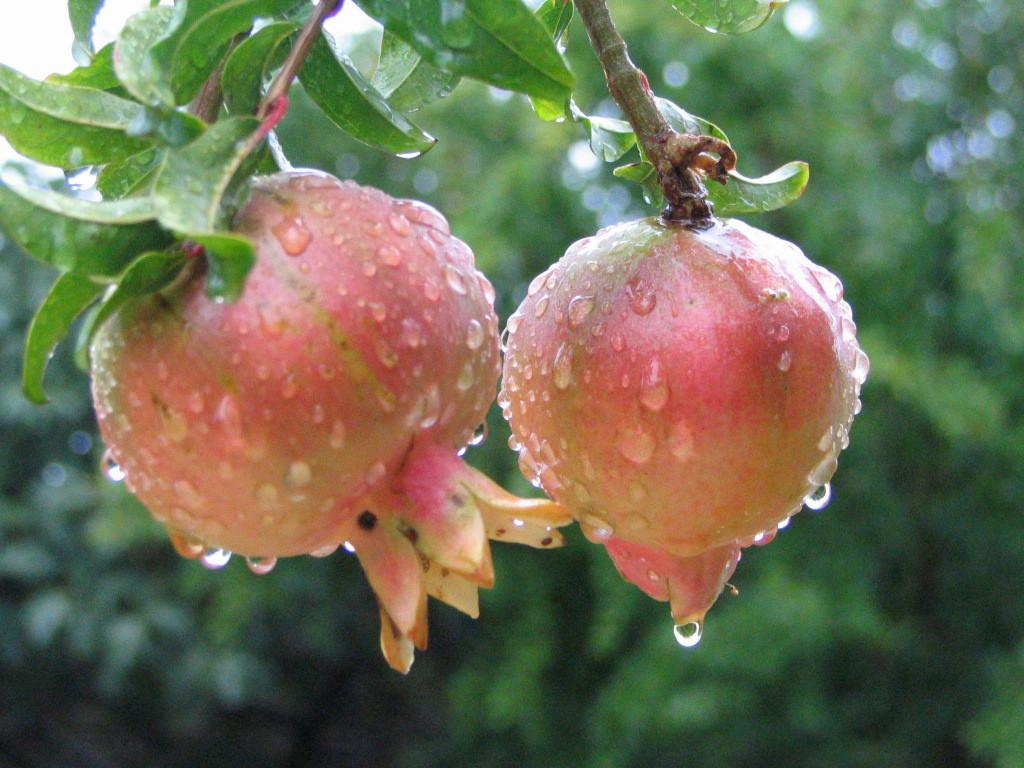How many pomegranates are in the image? There are two pomegranates in the image. What feature do the pomegranates have in common? The pomegranates have stems. What else can be seen in the image besides the pomegranates? There are leaves visible in the image. What type of oatmeal is being served in the image? There is no oatmeal present in the image; it features two pomegranates with stems and leaves. Can you hear the pomegranates laughing in the image? Pomegranates do not have the ability to laugh, and there is no sound in the image. 